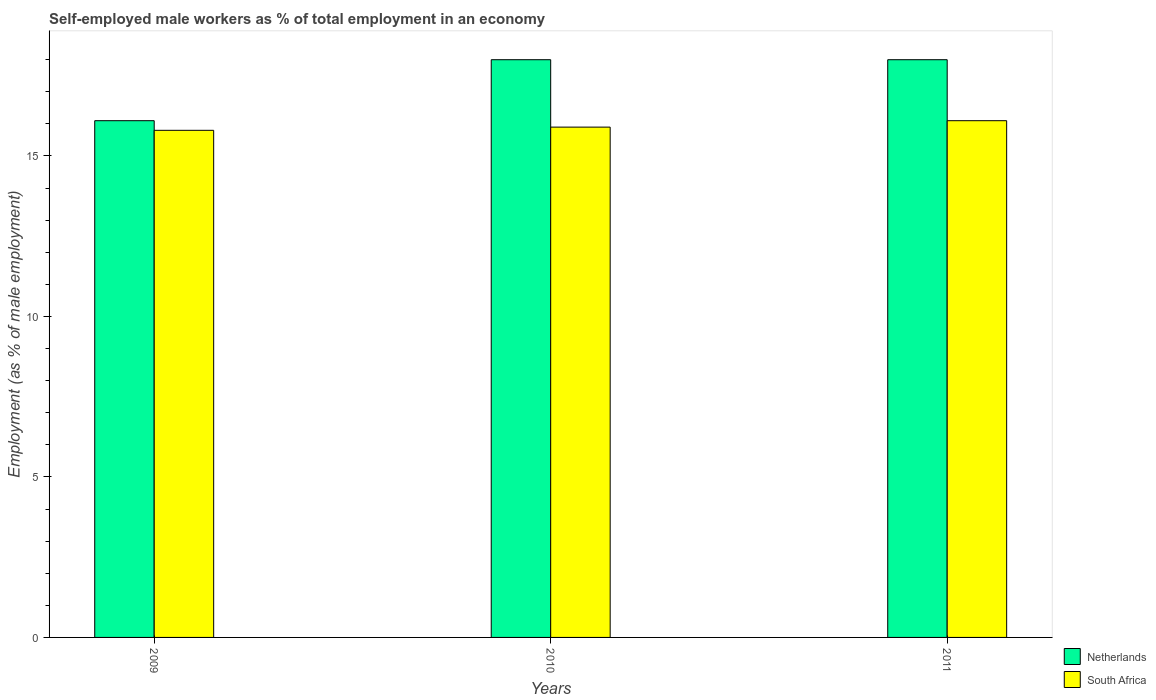How many bars are there on the 1st tick from the left?
Offer a terse response. 2. How many bars are there on the 3rd tick from the right?
Offer a terse response. 2. What is the label of the 3rd group of bars from the left?
Ensure brevity in your answer.  2011. In how many cases, is the number of bars for a given year not equal to the number of legend labels?
Offer a very short reply. 0. What is the percentage of self-employed male workers in South Africa in 2009?
Ensure brevity in your answer.  15.8. Across all years, what is the maximum percentage of self-employed male workers in Netherlands?
Make the answer very short. 18. Across all years, what is the minimum percentage of self-employed male workers in South Africa?
Offer a very short reply. 15.8. What is the total percentage of self-employed male workers in Netherlands in the graph?
Your response must be concise. 52.1. What is the difference between the percentage of self-employed male workers in South Africa in 2009 and that in 2010?
Your answer should be very brief. -0.1. What is the difference between the percentage of self-employed male workers in Netherlands in 2010 and the percentage of self-employed male workers in South Africa in 2009?
Give a very brief answer. 2.2. What is the average percentage of self-employed male workers in South Africa per year?
Keep it short and to the point. 15.93. In the year 2009, what is the difference between the percentage of self-employed male workers in South Africa and percentage of self-employed male workers in Netherlands?
Keep it short and to the point. -0.3. What is the ratio of the percentage of self-employed male workers in South Africa in 2009 to that in 2011?
Provide a short and direct response. 0.98. Is the percentage of self-employed male workers in Netherlands in 2010 less than that in 2011?
Keep it short and to the point. No. What is the difference between the highest and the lowest percentage of self-employed male workers in Netherlands?
Your response must be concise. 1.9. In how many years, is the percentage of self-employed male workers in Netherlands greater than the average percentage of self-employed male workers in Netherlands taken over all years?
Your answer should be compact. 2. Is the sum of the percentage of self-employed male workers in South Africa in 2009 and 2011 greater than the maximum percentage of self-employed male workers in Netherlands across all years?
Your response must be concise. Yes. What does the 1st bar from the left in 2010 represents?
Ensure brevity in your answer.  Netherlands. What does the 2nd bar from the right in 2010 represents?
Your answer should be very brief. Netherlands. How many years are there in the graph?
Keep it short and to the point. 3. Does the graph contain any zero values?
Keep it short and to the point. No. Does the graph contain grids?
Your response must be concise. No. Where does the legend appear in the graph?
Ensure brevity in your answer.  Bottom right. How many legend labels are there?
Your answer should be compact. 2. What is the title of the graph?
Keep it short and to the point. Self-employed male workers as % of total employment in an economy. Does "Iceland" appear as one of the legend labels in the graph?
Your answer should be very brief. No. What is the label or title of the Y-axis?
Make the answer very short. Employment (as % of male employment). What is the Employment (as % of male employment) in Netherlands in 2009?
Your response must be concise. 16.1. What is the Employment (as % of male employment) of South Africa in 2009?
Give a very brief answer. 15.8. What is the Employment (as % of male employment) of Netherlands in 2010?
Your answer should be compact. 18. What is the Employment (as % of male employment) in South Africa in 2010?
Offer a terse response. 15.9. What is the Employment (as % of male employment) in South Africa in 2011?
Give a very brief answer. 16.1. Across all years, what is the maximum Employment (as % of male employment) in South Africa?
Provide a short and direct response. 16.1. Across all years, what is the minimum Employment (as % of male employment) of Netherlands?
Provide a succinct answer. 16.1. Across all years, what is the minimum Employment (as % of male employment) in South Africa?
Give a very brief answer. 15.8. What is the total Employment (as % of male employment) of Netherlands in the graph?
Keep it short and to the point. 52.1. What is the total Employment (as % of male employment) in South Africa in the graph?
Make the answer very short. 47.8. What is the difference between the Employment (as % of male employment) of Netherlands in 2009 and that in 2010?
Your answer should be compact. -1.9. What is the difference between the Employment (as % of male employment) of South Africa in 2009 and that in 2010?
Your answer should be very brief. -0.1. What is the difference between the Employment (as % of male employment) of Netherlands in 2010 and that in 2011?
Provide a succinct answer. 0. What is the difference between the Employment (as % of male employment) of South Africa in 2010 and that in 2011?
Offer a terse response. -0.2. What is the average Employment (as % of male employment) of Netherlands per year?
Provide a succinct answer. 17.37. What is the average Employment (as % of male employment) in South Africa per year?
Provide a short and direct response. 15.93. In the year 2009, what is the difference between the Employment (as % of male employment) in Netherlands and Employment (as % of male employment) in South Africa?
Give a very brief answer. 0.3. In the year 2010, what is the difference between the Employment (as % of male employment) in Netherlands and Employment (as % of male employment) in South Africa?
Your answer should be compact. 2.1. What is the ratio of the Employment (as % of male employment) of Netherlands in 2009 to that in 2010?
Your answer should be very brief. 0.89. What is the ratio of the Employment (as % of male employment) in South Africa in 2009 to that in 2010?
Your response must be concise. 0.99. What is the ratio of the Employment (as % of male employment) of Netherlands in 2009 to that in 2011?
Offer a very short reply. 0.89. What is the ratio of the Employment (as % of male employment) of South Africa in 2009 to that in 2011?
Provide a succinct answer. 0.98. What is the ratio of the Employment (as % of male employment) of South Africa in 2010 to that in 2011?
Your answer should be very brief. 0.99. What is the difference between the highest and the second highest Employment (as % of male employment) in Netherlands?
Keep it short and to the point. 0. 